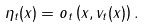Convert formula to latex. <formula><loc_0><loc_0><loc_500><loc_500>\eta _ { t } ( x ) = o _ { t } \left ( x , v _ { t } ( x ) \right ) .</formula> 